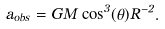Convert formula to latex. <formula><loc_0><loc_0><loc_500><loc_500>a _ { o b s } = G M \cos ^ { 3 } ( \theta ) R ^ { - 2 } .</formula> 